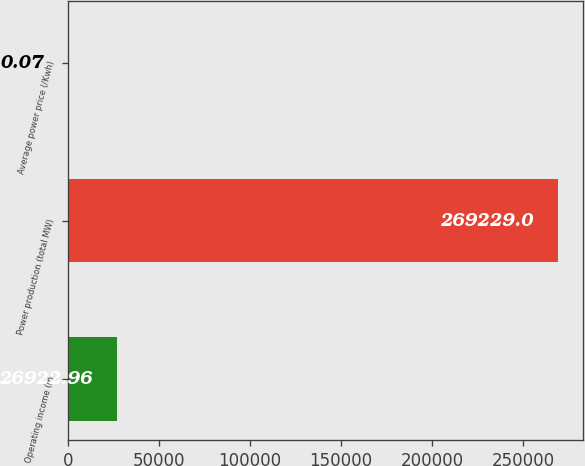Convert chart. <chart><loc_0><loc_0><loc_500><loc_500><bar_chart><fcel>Operating income (in<fcel>Power production (total MW)<fcel>Average power price (/Kwh)<nl><fcel>26923<fcel>269229<fcel>0.07<nl></chart> 